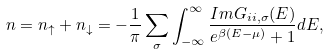<formula> <loc_0><loc_0><loc_500><loc_500>n = n _ { \uparrow } + n _ { \downarrow } = - \frac { 1 } { \pi } \sum _ { \sigma } \int ^ { \infty } _ { - \infty } \frac { I m G _ { i i , \sigma } ( E ) } { e ^ { \beta ( E - \mu ) } + 1 } d E ,</formula> 